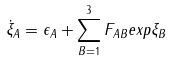<formula> <loc_0><loc_0><loc_500><loc_500>\dot { \xi } _ { A } = \epsilon _ { A } + \sum _ { B = 1 } ^ { 3 } F _ { A B } e x p \xi _ { B }</formula> 